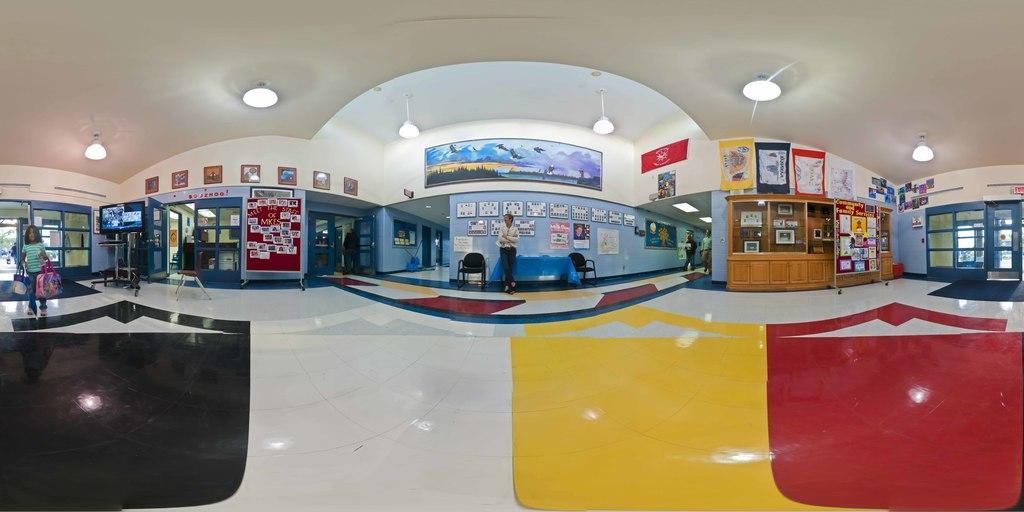Can you describe this image briefly? This picture shows inner view of a building. We see few flags and photo frames on the wall and we see a television and a human standing holding papers in the hand and we see couple of them walking and we see few lights to the roof and we see a cupboard on the side. We see a girl standing holding couple of bags in her hands and we see few chairs and a table. 